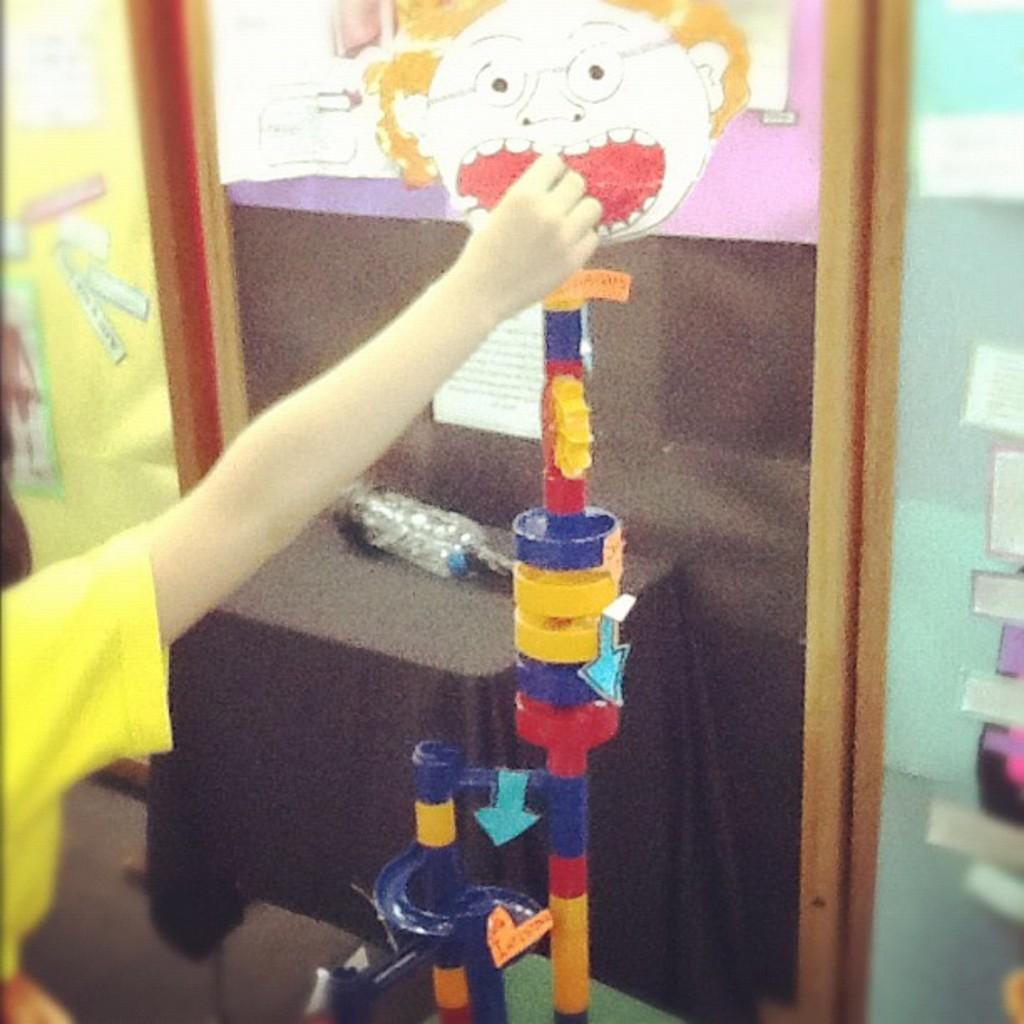In one or two sentences, can you explain what this image depicts? This image consists of a toy. There is a water bottle in the middle. There is a person's hand in the middle. 